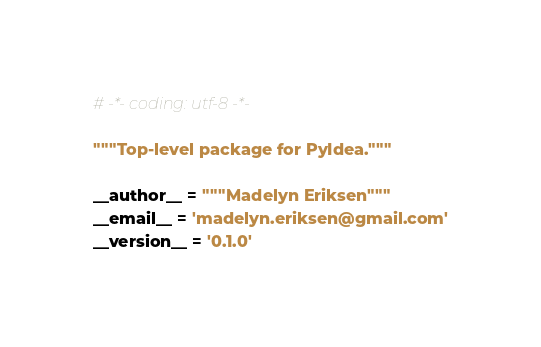<code> <loc_0><loc_0><loc_500><loc_500><_Python_># -*- coding: utf-8 -*-

"""Top-level package for PyIdea."""

__author__ = """Madelyn Eriksen"""
__email__ = 'madelyn.eriksen@gmail.com'
__version__ = '0.1.0'
</code> 